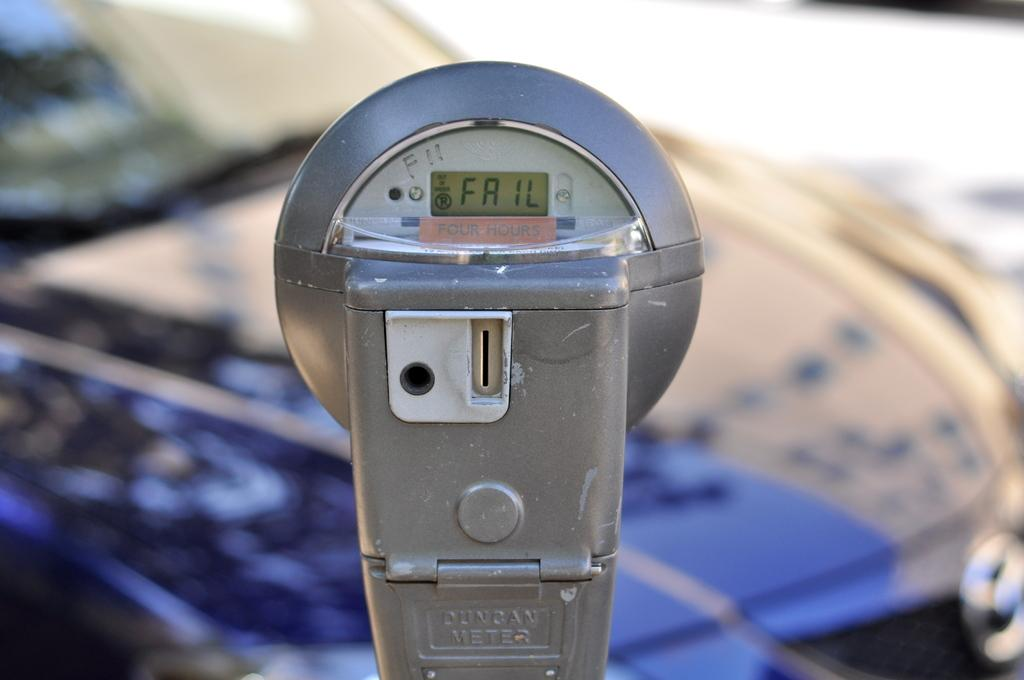<image>
Relay a brief, clear account of the picture shown. A parking meter says FAIL on its screen. 